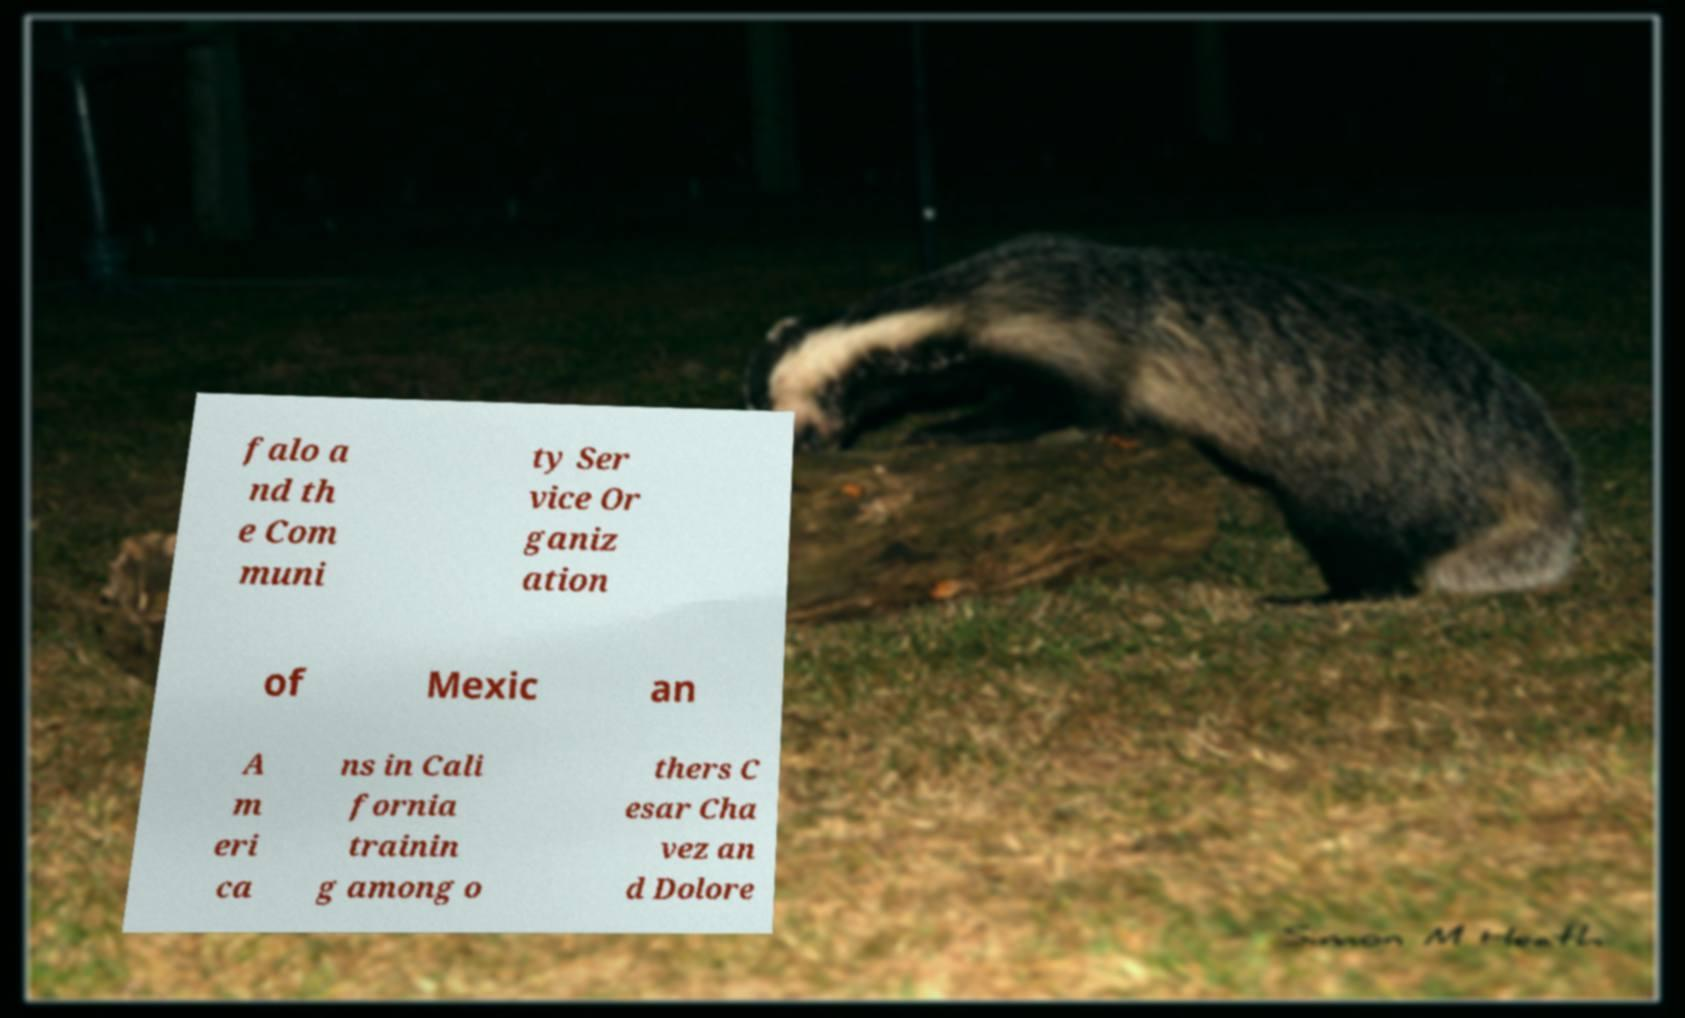For documentation purposes, I need the text within this image transcribed. Could you provide that? falo a nd th e Com muni ty Ser vice Or ganiz ation of Mexic an A m eri ca ns in Cali fornia trainin g among o thers C esar Cha vez an d Dolore 